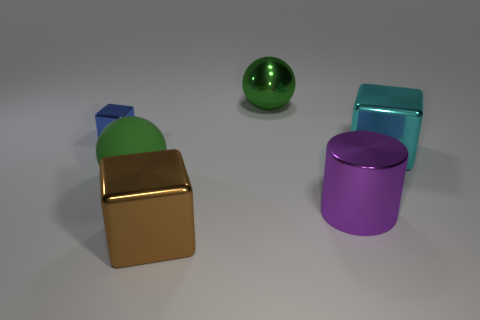What is the size of the cyan cube that is made of the same material as the brown block?
Your answer should be compact. Large. Are there more balls in front of the large cyan metal cube than cyan things behind the metallic sphere?
Ensure brevity in your answer.  Yes. How many other objects are the same material as the brown object?
Make the answer very short. 4. Are the green ball that is in front of the cyan block and the big brown object made of the same material?
Your response must be concise. No. What is the shape of the large green metal thing?
Make the answer very short. Sphere. Is the number of big things that are in front of the large purple object greater than the number of big brown rubber things?
Offer a very short reply. Yes. Are there any other things that have the same shape as the purple thing?
Provide a succinct answer. No. What color is the small shiny thing that is the same shape as the big cyan metallic thing?
Provide a short and direct response. Blue. What is the shape of the big thing that is behind the tiny blue metal cube?
Your answer should be compact. Sphere. There is a green rubber sphere; are there any large cyan blocks to the left of it?
Ensure brevity in your answer.  No. 